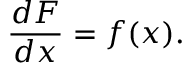Convert formula to latex. <formula><loc_0><loc_0><loc_500><loc_500>{ \frac { d F } { d x } } = f ( x ) .</formula> 